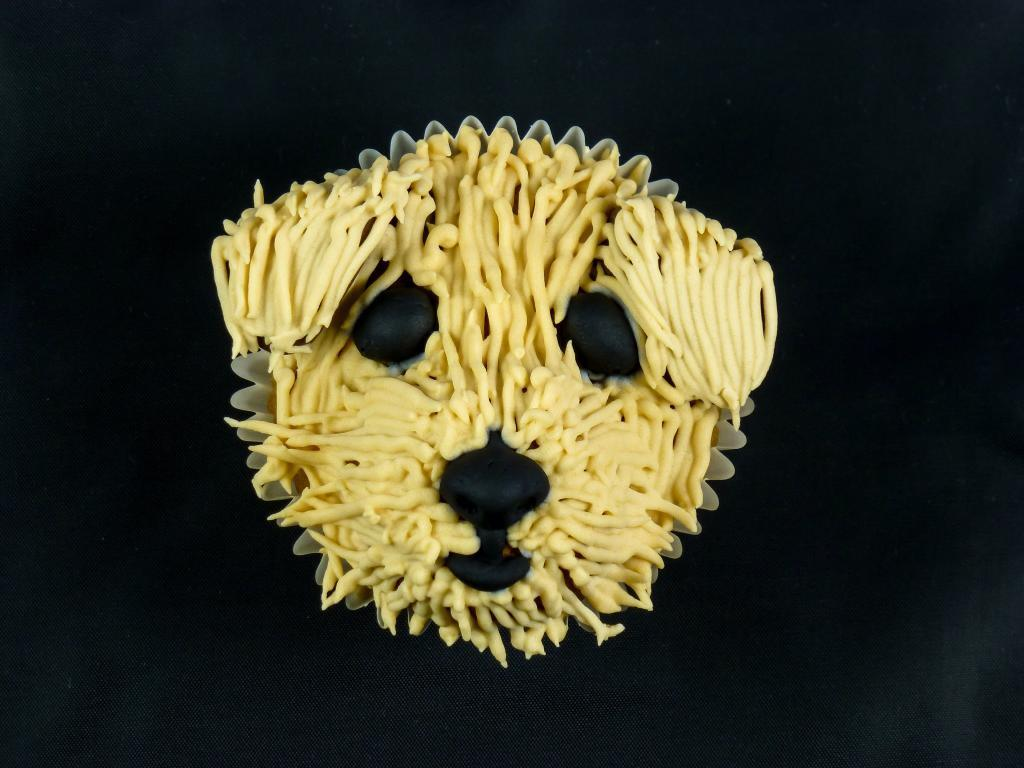What is on the plate in the image? There are food items on a plate in the image. Can you describe the background of the image? The background of the image is dark. What type of drug is being used by the pet in the image? There is no pet or drug present in the image. 